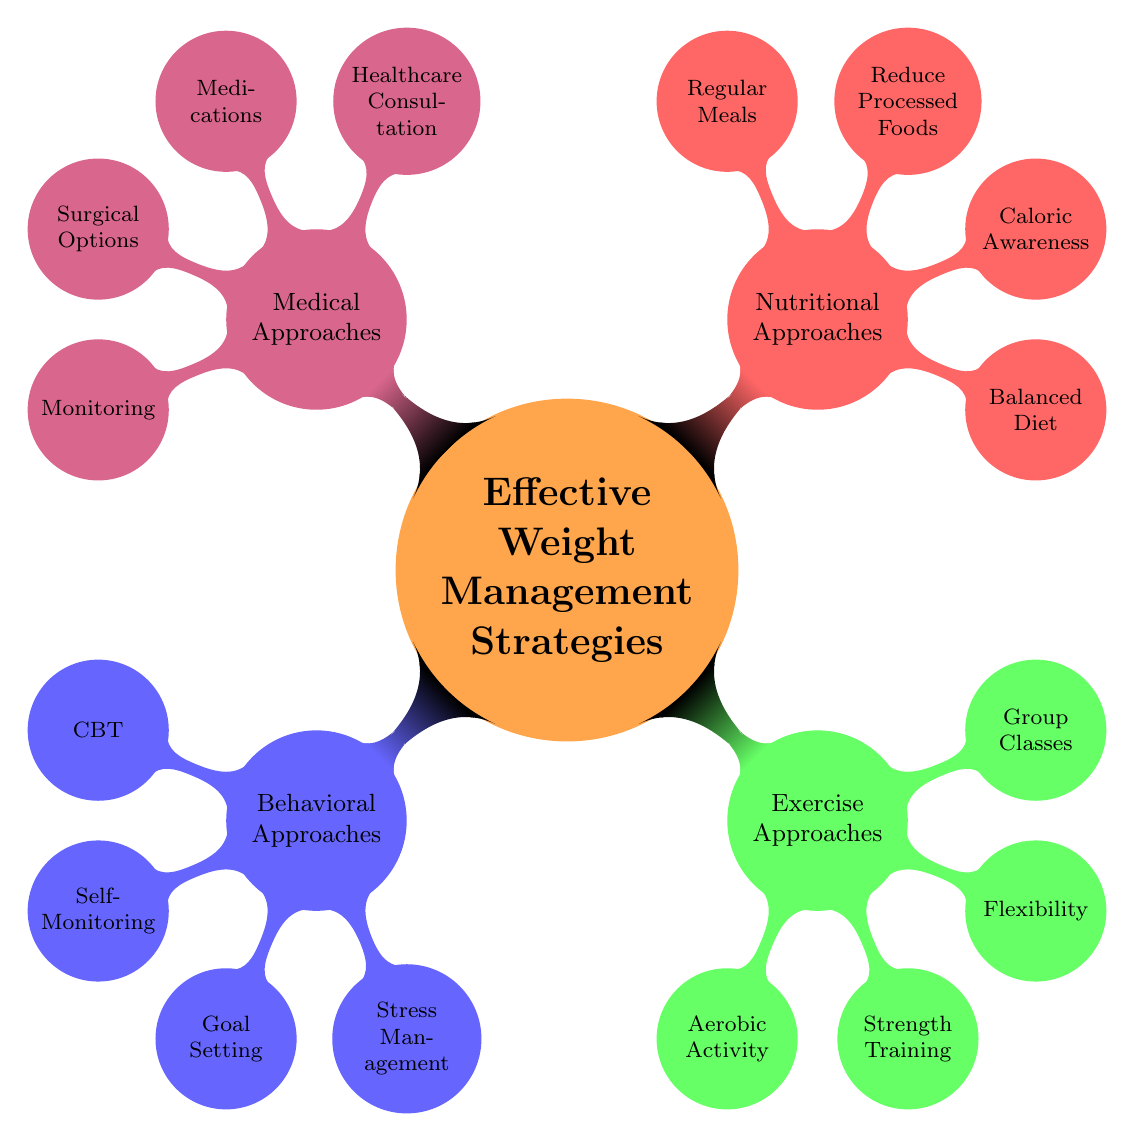What are the four main categories of effective weight management strategies? The diagram displays four primary categories: Behavioral Approaches, Exercise Approaches, Nutritional Approaches, and Medical Approaches. Each category is color-coded and positioned around the central node.
Answer: Behavioral Approaches, Exercise Approaches, Nutritional Approaches, Medical Approaches How many elements are listed under Exercise Approaches? By examining the Exercise Approaches section, there are four elements provided: Regular Aerobic Activity, Strength Training, Flexibility and Stretching, and Group Exercise Classes. Thus, counting these gives us a total of four elements.
Answer: 4 Which node represents a technique for stress management? In the Behavioral Approaches section, one of the nodes is specifically labeled Stress Management Techniques, which indicates the associated technique.
Answer: Stress Management Techniques What is one of the medical approaches listed in the diagram? The Medical Approaches category includes several elements. One listed element is the Consultation with a Healthcare Provider, highlighting the type of medical approach available.
Answer: Consultation with a Healthcare Provider Which approach emphasizes caloric awareness? The Nutritional Approaches section lists Caloric Awareness as one of its elements, emphasizing its importance in weight management strategies.
Answer: Caloric Awareness What color represents Nutritional Approaches in the diagram? The diagram's color scheme assigns the red color to the Nutritional Approaches node, which can be visually identified on the mind map.
Answer: Red Name two types of exercise approaches mentioned. Within the Exercise Approaches section, two of the specific nodes are Regular Aerobic Activity and Strength Training. These two are part of the four total elements listed under this category.
Answer: Regular Aerobic Activity, Strength Training How many different nodes are there under Medical Approaches? The Medical Approaches category consists of four nodes, which are Healthcare Consultation, Medications, Surgical Options, and Monitoring. Counting these gives us a total of four different nodes.
Answer: 4 Which behavioral approach includes goal setting? The Goal Setting and Planning node falls under the Behavioral Approaches section, which directly addresses the focus on goal setting strategies.
Answer: Goal Setting and Planning 